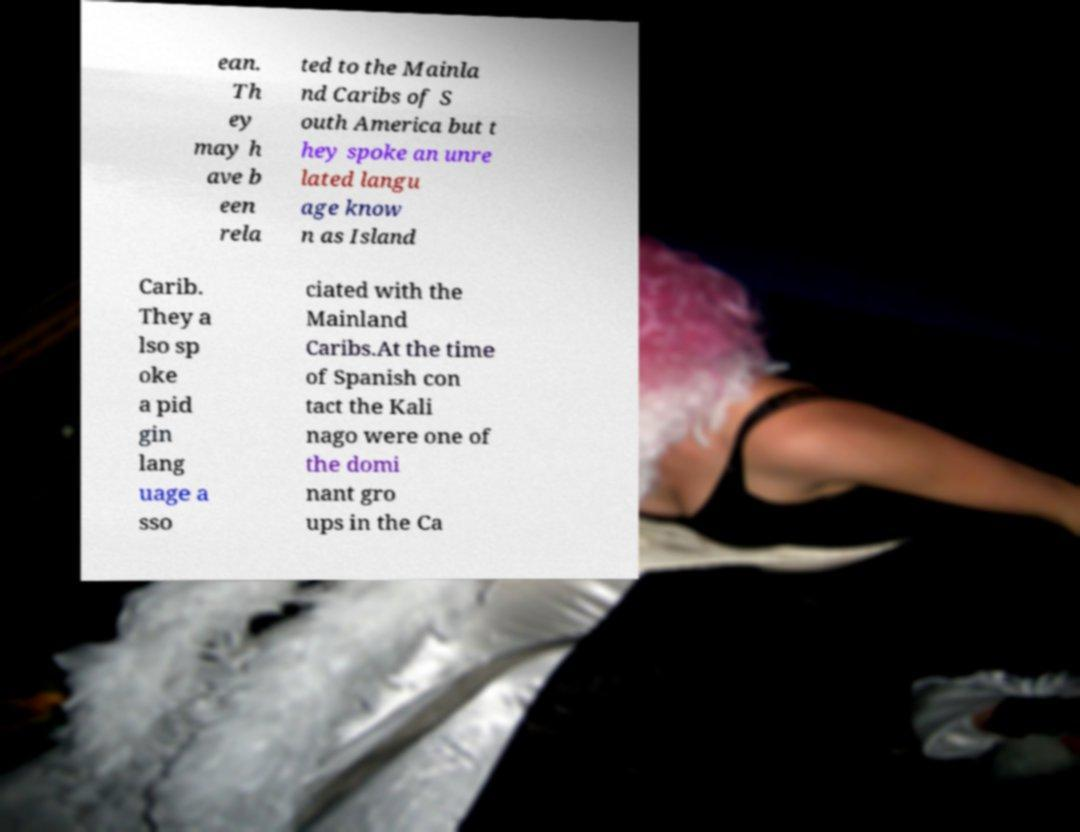Please read and relay the text visible in this image. What does it say? ean. Th ey may h ave b een rela ted to the Mainla nd Caribs of S outh America but t hey spoke an unre lated langu age know n as Island Carib. They a lso sp oke a pid gin lang uage a sso ciated with the Mainland Caribs.At the time of Spanish con tact the Kali nago were one of the domi nant gro ups in the Ca 